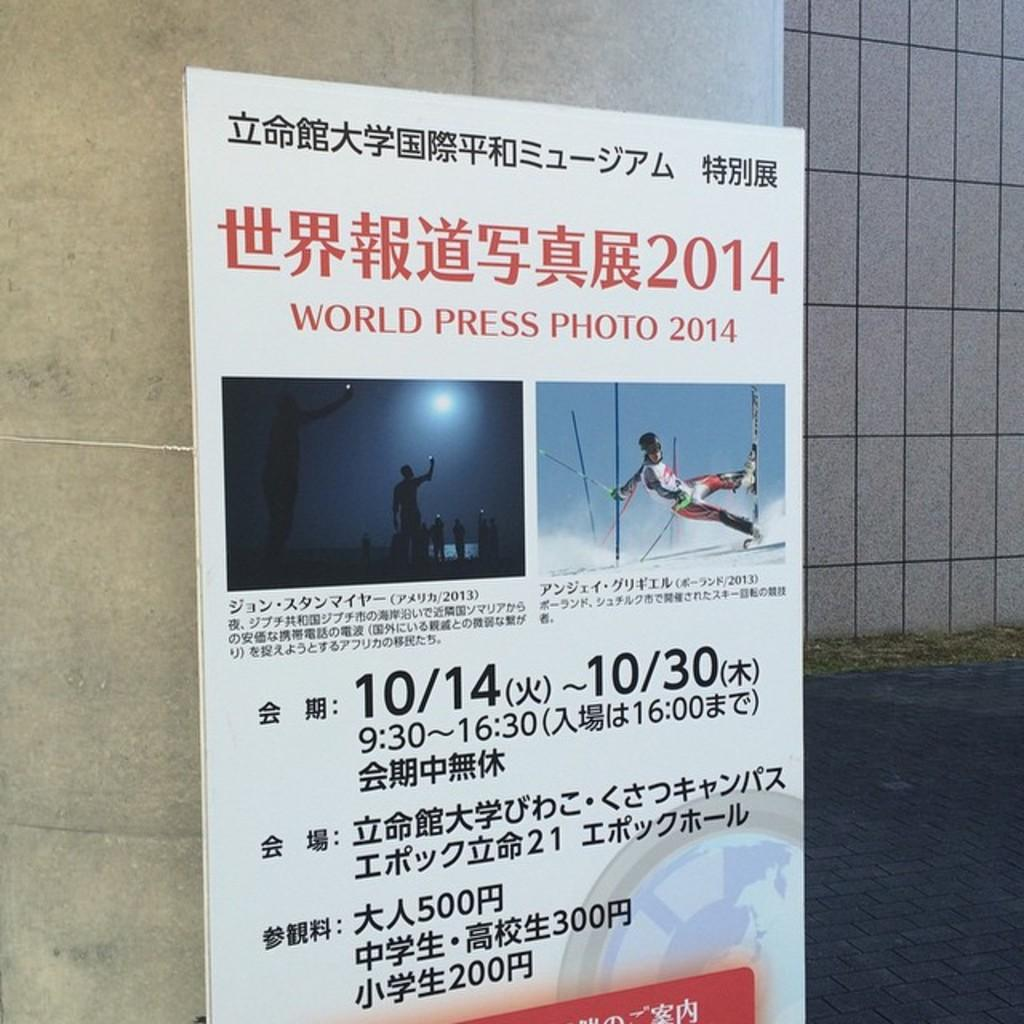<image>
Present a compact description of the photo's key features. A poster that says World Press Photo 2014. 